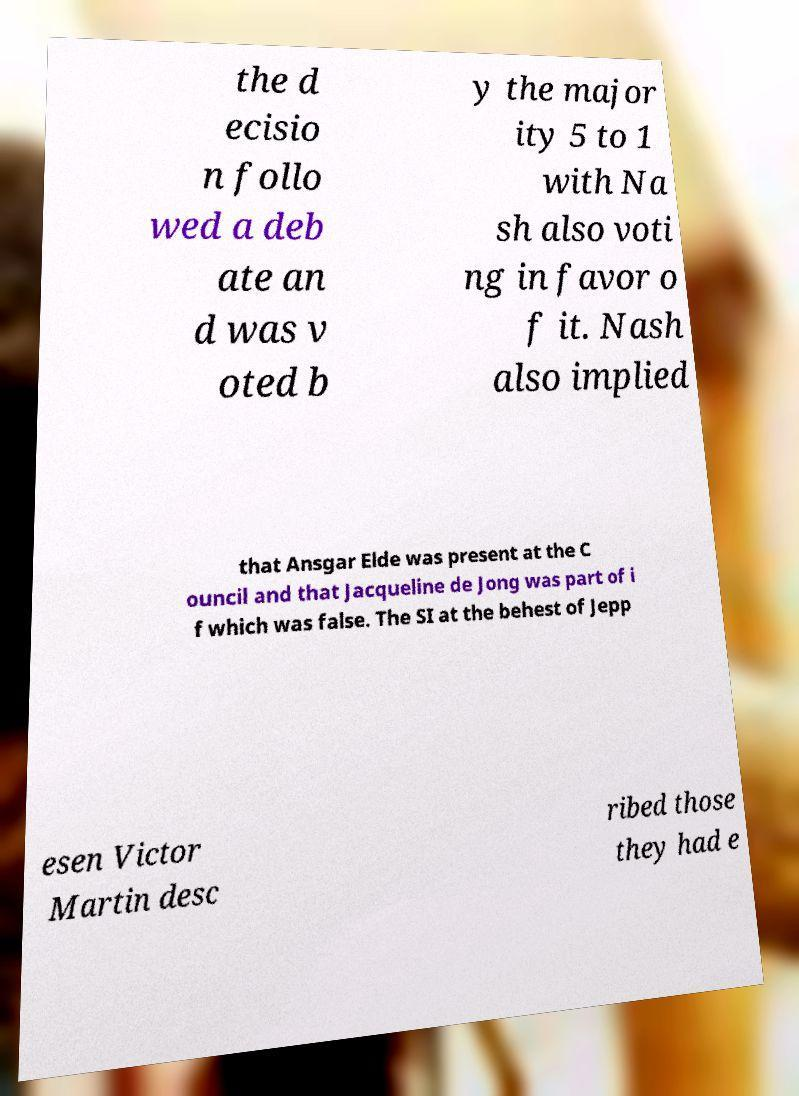Please read and relay the text visible in this image. What does it say? the d ecisio n follo wed a deb ate an d was v oted b y the major ity 5 to 1 with Na sh also voti ng in favor o f it. Nash also implied that Ansgar Elde was present at the C ouncil and that Jacqueline de Jong was part of i f which was false. The SI at the behest of Jepp esen Victor Martin desc ribed those they had e 